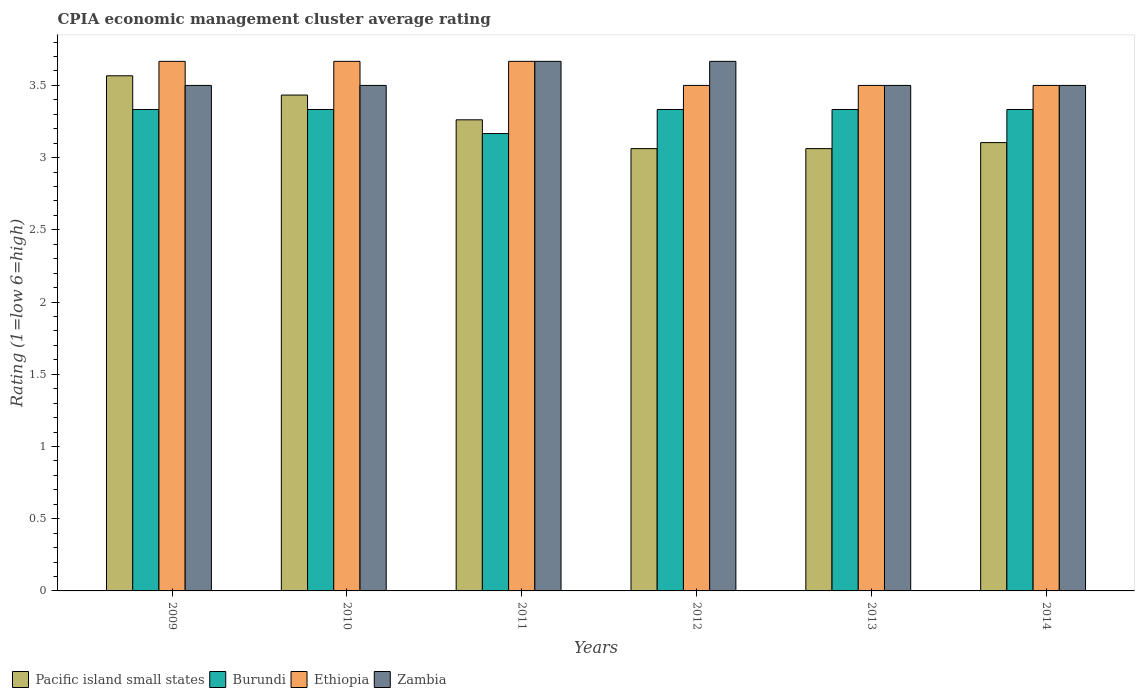Are the number of bars per tick equal to the number of legend labels?
Offer a very short reply. Yes. How many bars are there on the 2nd tick from the left?
Make the answer very short. 4. How many bars are there on the 4th tick from the right?
Your answer should be very brief. 4. What is the label of the 5th group of bars from the left?
Your answer should be very brief. 2013. What is the CPIA rating in Ethiopia in 2011?
Your response must be concise. 3.67. Across all years, what is the maximum CPIA rating in Zambia?
Ensure brevity in your answer.  3.67. Across all years, what is the minimum CPIA rating in Pacific island small states?
Keep it short and to the point. 3.06. What is the total CPIA rating in Zambia in the graph?
Provide a succinct answer. 21.33. What is the difference between the CPIA rating in Burundi in 2009 and that in 2013?
Provide a succinct answer. 0. What is the difference between the CPIA rating in Zambia in 2009 and the CPIA rating in Pacific island small states in 2013?
Provide a short and direct response. 0.44. What is the average CPIA rating in Pacific island small states per year?
Your answer should be very brief. 3.25. In the year 2012, what is the difference between the CPIA rating in Burundi and CPIA rating in Zambia?
Give a very brief answer. -0.33. What is the ratio of the CPIA rating in Burundi in 2009 to that in 2011?
Provide a short and direct response. 1.05. Is the difference between the CPIA rating in Burundi in 2013 and 2014 greater than the difference between the CPIA rating in Zambia in 2013 and 2014?
Provide a short and direct response. Yes. What is the difference between the highest and the second highest CPIA rating in Ethiopia?
Provide a short and direct response. 0. What is the difference between the highest and the lowest CPIA rating in Ethiopia?
Keep it short and to the point. 0.17. Is the sum of the CPIA rating in Burundi in 2011 and 2014 greater than the maximum CPIA rating in Pacific island small states across all years?
Your answer should be compact. Yes. What does the 3rd bar from the left in 2013 represents?
Offer a terse response. Ethiopia. What does the 1st bar from the right in 2011 represents?
Make the answer very short. Zambia. Is it the case that in every year, the sum of the CPIA rating in Zambia and CPIA rating in Burundi is greater than the CPIA rating in Pacific island small states?
Make the answer very short. Yes. How many years are there in the graph?
Provide a short and direct response. 6. Does the graph contain grids?
Your response must be concise. No. What is the title of the graph?
Provide a short and direct response. CPIA economic management cluster average rating. What is the Rating (1=low 6=high) in Pacific island small states in 2009?
Provide a succinct answer. 3.57. What is the Rating (1=low 6=high) in Burundi in 2009?
Give a very brief answer. 3.33. What is the Rating (1=low 6=high) of Ethiopia in 2009?
Offer a very short reply. 3.67. What is the Rating (1=low 6=high) of Pacific island small states in 2010?
Provide a short and direct response. 3.43. What is the Rating (1=low 6=high) in Burundi in 2010?
Keep it short and to the point. 3.33. What is the Rating (1=low 6=high) in Ethiopia in 2010?
Give a very brief answer. 3.67. What is the Rating (1=low 6=high) in Zambia in 2010?
Your answer should be very brief. 3.5. What is the Rating (1=low 6=high) in Pacific island small states in 2011?
Offer a terse response. 3.26. What is the Rating (1=low 6=high) of Burundi in 2011?
Your response must be concise. 3.17. What is the Rating (1=low 6=high) in Ethiopia in 2011?
Your response must be concise. 3.67. What is the Rating (1=low 6=high) in Zambia in 2011?
Offer a very short reply. 3.67. What is the Rating (1=low 6=high) of Pacific island small states in 2012?
Ensure brevity in your answer.  3.06. What is the Rating (1=low 6=high) in Burundi in 2012?
Provide a short and direct response. 3.33. What is the Rating (1=low 6=high) in Ethiopia in 2012?
Provide a succinct answer. 3.5. What is the Rating (1=low 6=high) of Zambia in 2012?
Provide a succinct answer. 3.67. What is the Rating (1=low 6=high) of Pacific island small states in 2013?
Provide a short and direct response. 3.06. What is the Rating (1=low 6=high) of Burundi in 2013?
Provide a short and direct response. 3.33. What is the Rating (1=low 6=high) of Ethiopia in 2013?
Provide a succinct answer. 3.5. What is the Rating (1=low 6=high) in Zambia in 2013?
Keep it short and to the point. 3.5. What is the Rating (1=low 6=high) in Pacific island small states in 2014?
Your answer should be very brief. 3.1. What is the Rating (1=low 6=high) of Burundi in 2014?
Ensure brevity in your answer.  3.33. Across all years, what is the maximum Rating (1=low 6=high) of Pacific island small states?
Provide a succinct answer. 3.57. Across all years, what is the maximum Rating (1=low 6=high) in Burundi?
Provide a short and direct response. 3.33. Across all years, what is the maximum Rating (1=low 6=high) of Ethiopia?
Give a very brief answer. 3.67. Across all years, what is the maximum Rating (1=low 6=high) of Zambia?
Provide a short and direct response. 3.67. Across all years, what is the minimum Rating (1=low 6=high) of Pacific island small states?
Your answer should be compact. 3.06. Across all years, what is the minimum Rating (1=low 6=high) in Burundi?
Your response must be concise. 3.17. Across all years, what is the minimum Rating (1=low 6=high) in Zambia?
Offer a very short reply. 3.5. What is the total Rating (1=low 6=high) of Pacific island small states in the graph?
Your answer should be very brief. 19.49. What is the total Rating (1=low 6=high) in Burundi in the graph?
Your answer should be compact. 19.83. What is the total Rating (1=low 6=high) of Zambia in the graph?
Ensure brevity in your answer.  21.33. What is the difference between the Rating (1=low 6=high) in Pacific island small states in 2009 and that in 2010?
Your answer should be very brief. 0.13. What is the difference between the Rating (1=low 6=high) of Zambia in 2009 and that in 2010?
Your response must be concise. 0. What is the difference between the Rating (1=low 6=high) of Pacific island small states in 2009 and that in 2011?
Ensure brevity in your answer.  0.3. What is the difference between the Rating (1=low 6=high) in Burundi in 2009 and that in 2011?
Your response must be concise. 0.17. What is the difference between the Rating (1=low 6=high) in Pacific island small states in 2009 and that in 2012?
Keep it short and to the point. 0.5. What is the difference between the Rating (1=low 6=high) in Zambia in 2009 and that in 2012?
Make the answer very short. -0.17. What is the difference between the Rating (1=low 6=high) in Pacific island small states in 2009 and that in 2013?
Keep it short and to the point. 0.5. What is the difference between the Rating (1=low 6=high) of Burundi in 2009 and that in 2013?
Provide a succinct answer. 0. What is the difference between the Rating (1=low 6=high) of Zambia in 2009 and that in 2013?
Provide a short and direct response. 0. What is the difference between the Rating (1=low 6=high) in Pacific island small states in 2009 and that in 2014?
Ensure brevity in your answer.  0.46. What is the difference between the Rating (1=low 6=high) of Zambia in 2009 and that in 2014?
Your answer should be very brief. 0. What is the difference between the Rating (1=low 6=high) in Pacific island small states in 2010 and that in 2011?
Offer a very short reply. 0.17. What is the difference between the Rating (1=low 6=high) of Burundi in 2010 and that in 2011?
Offer a very short reply. 0.17. What is the difference between the Rating (1=low 6=high) in Zambia in 2010 and that in 2011?
Provide a succinct answer. -0.17. What is the difference between the Rating (1=low 6=high) in Pacific island small states in 2010 and that in 2012?
Offer a very short reply. 0.37. What is the difference between the Rating (1=low 6=high) of Burundi in 2010 and that in 2012?
Your response must be concise. 0. What is the difference between the Rating (1=low 6=high) of Ethiopia in 2010 and that in 2012?
Make the answer very short. 0.17. What is the difference between the Rating (1=low 6=high) of Pacific island small states in 2010 and that in 2013?
Provide a short and direct response. 0.37. What is the difference between the Rating (1=low 6=high) in Burundi in 2010 and that in 2013?
Offer a terse response. 0. What is the difference between the Rating (1=low 6=high) in Zambia in 2010 and that in 2013?
Your response must be concise. 0. What is the difference between the Rating (1=low 6=high) in Pacific island small states in 2010 and that in 2014?
Offer a terse response. 0.33. What is the difference between the Rating (1=low 6=high) of Burundi in 2010 and that in 2014?
Your response must be concise. 0. What is the difference between the Rating (1=low 6=high) in Zambia in 2010 and that in 2014?
Provide a short and direct response. 0. What is the difference between the Rating (1=low 6=high) of Pacific island small states in 2011 and that in 2012?
Your answer should be very brief. 0.2. What is the difference between the Rating (1=low 6=high) of Burundi in 2011 and that in 2012?
Make the answer very short. -0.17. What is the difference between the Rating (1=low 6=high) of Ethiopia in 2011 and that in 2012?
Keep it short and to the point. 0.17. What is the difference between the Rating (1=low 6=high) in Zambia in 2011 and that in 2012?
Ensure brevity in your answer.  0. What is the difference between the Rating (1=low 6=high) in Pacific island small states in 2011 and that in 2013?
Your answer should be very brief. 0.2. What is the difference between the Rating (1=low 6=high) of Burundi in 2011 and that in 2013?
Offer a very short reply. -0.17. What is the difference between the Rating (1=low 6=high) in Ethiopia in 2011 and that in 2013?
Your answer should be very brief. 0.17. What is the difference between the Rating (1=low 6=high) in Pacific island small states in 2011 and that in 2014?
Provide a short and direct response. 0.16. What is the difference between the Rating (1=low 6=high) of Burundi in 2011 and that in 2014?
Your answer should be compact. -0.17. What is the difference between the Rating (1=low 6=high) in Pacific island small states in 2012 and that in 2013?
Ensure brevity in your answer.  0. What is the difference between the Rating (1=low 6=high) of Ethiopia in 2012 and that in 2013?
Your answer should be very brief. 0. What is the difference between the Rating (1=low 6=high) of Zambia in 2012 and that in 2013?
Give a very brief answer. 0.17. What is the difference between the Rating (1=low 6=high) of Pacific island small states in 2012 and that in 2014?
Your response must be concise. -0.04. What is the difference between the Rating (1=low 6=high) in Ethiopia in 2012 and that in 2014?
Your answer should be compact. 0. What is the difference between the Rating (1=low 6=high) of Zambia in 2012 and that in 2014?
Provide a short and direct response. 0.17. What is the difference between the Rating (1=low 6=high) of Pacific island small states in 2013 and that in 2014?
Provide a succinct answer. -0.04. What is the difference between the Rating (1=low 6=high) of Burundi in 2013 and that in 2014?
Keep it short and to the point. 0. What is the difference between the Rating (1=low 6=high) of Ethiopia in 2013 and that in 2014?
Your answer should be very brief. 0. What is the difference between the Rating (1=low 6=high) of Pacific island small states in 2009 and the Rating (1=low 6=high) of Burundi in 2010?
Provide a succinct answer. 0.23. What is the difference between the Rating (1=low 6=high) in Pacific island small states in 2009 and the Rating (1=low 6=high) in Ethiopia in 2010?
Offer a very short reply. -0.1. What is the difference between the Rating (1=low 6=high) in Pacific island small states in 2009 and the Rating (1=low 6=high) in Zambia in 2010?
Offer a very short reply. 0.07. What is the difference between the Rating (1=low 6=high) of Burundi in 2009 and the Rating (1=low 6=high) of Ethiopia in 2010?
Provide a succinct answer. -0.33. What is the difference between the Rating (1=low 6=high) in Burundi in 2009 and the Rating (1=low 6=high) in Zambia in 2010?
Ensure brevity in your answer.  -0.17. What is the difference between the Rating (1=low 6=high) in Burundi in 2009 and the Rating (1=low 6=high) in Zambia in 2011?
Your answer should be very brief. -0.33. What is the difference between the Rating (1=low 6=high) in Pacific island small states in 2009 and the Rating (1=low 6=high) in Burundi in 2012?
Give a very brief answer. 0.23. What is the difference between the Rating (1=low 6=high) of Pacific island small states in 2009 and the Rating (1=low 6=high) of Ethiopia in 2012?
Ensure brevity in your answer.  0.07. What is the difference between the Rating (1=low 6=high) in Pacific island small states in 2009 and the Rating (1=low 6=high) in Zambia in 2012?
Your answer should be very brief. -0.1. What is the difference between the Rating (1=low 6=high) of Burundi in 2009 and the Rating (1=low 6=high) of Zambia in 2012?
Your response must be concise. -0.33. What is the difference between the Rating (1=low 6=high) of Pacific island small states in 2009 and the Rating (1=low 6=high) of Burundi in 2013?
Offer a very short reply. 0.23. What is the difference between the Rating (1=low 6=high) of Pacific island small states in 2009 and the Rating (1=low 6=high) of Ethiopia in 2013?
Keep it short and to the point. 0.07. What is the difference between the Rating (1=low 6=high) in Pacific island small states in 2009 and the Rating (1=low 6=high) in Zambia in 2013?
Offer a terse response. 0.07. What is the difference between the Rating (1=low 6=high) in Burundi in 2009 and the Rating (1=low 6=high) in Ethiopia in 2013?
Provide a succinct answer. -0.17. What is the difference between the Rating (1=low 6=high) in Burundi in 2009 and the Rating (1=low 6=high) in Zambia in 2013?
Your response must be concise. -0.17. What is the difference between the Rating (1=low 6=high) in Ethiopia in 2009 and the Rating (1=low 6=high) in Zambia in 2013?
Keep it short and to the point. 0.17. What is the difference between the Rating (1=low 6=high) of Pacific island small states in 2009 and the Rating (1=low 6=high) of Burundi in 2014?
Your response must be concise. 0.23. What is the difference between the Rating (1=low 6=high) of Pacific island small states in 2009 and the Rating (1=low 6=high) of Ethiopia in 2014?
Offer a terse response. 0.07. What is the difference between the Rating (1=low 6=high) in Pacific island small states in 2009 and the Rating (1=low 6=high) in Zambia in 2014?
Your response must be concise. 0.07. What is the difference between the Rating (1=low 6=high) in Burundi in 2009 and the Rating (1=low 6=high) in Zambia in 2014?
Offer a very short reply. -0.17. What is the difference between the Rating (1=low 6=high) in Pacific island small states in 2010 and the Rating (1=low 6=high) in Burundi in 2011?
Offer a terse response. 0.27. What is the difference between the Rating (1=low 6=high) in Pacific island small states in 2010 and the Rating (1=low 6=high) in Ethiopia in 2011?
Your response must be concise. -0.23. What is the difference between the Rating (1=low 6=high) of Pacific island small states in 2010 and the Rating (1=low 6=high) of Zambia in 2011?
Ensure brevity in your answer.  -0.23. What is the difference between the Rating (1=low 6=high) in Ethiopia in 2010 and the Rating (1=low 6=high) in Zambia in 2011?
Your answer should be compact. 0. What is the difference between the Rating (1=low 6=high) in Pacific island small states in 2010 and the Rating (1=low 6=high) in Burundi in 2012?
Give a very brief answer. 0.1. What is the difference between the Rating (1=low 6=high) of Pacific island small states in 2010 and the Rating (1=low 6=high) of Ethiopia in 2012?
Give a very brief answer. -0.07. What is the difference between the Rating (1=low 6=high) in Pacific island small states in 2010 and the Rating (1=low 6=high) in Zambia in 2012?
Ensure brevity in your answer.  -0.23. What is the difference between the Rating (1=low 6=high) of Burundi in 2010 and the Rating (1=low 6=high) of Ethiopia in 2012?
Make the answer very short. -0.17. What is the difference between the Rating (1=low 6=high) of Ethiopia in 2010 and the Rating (1=low 6=high) of Zambia in 2012?
Give a very brief answer. 0. What is the difference between the Rating (1=low 6=high) in Pacific island small states in 2010 and the Rating (1=low 6=high) in Burundi in 2013?
Provide a succinct answer. 0.1. What is the difference between the Rating (1=low 6=high) in Pacific island small states in 2010 and the Rating (1=low 6=high) in Ethiopia in 2013?
Keep it short and to the point. -0.07. What is the difference between the Rating (1=low 6=high) in Pacific island small states in 2010 and the Rating (1=low 6=high) in Zambia in 2013?
Ensure brevity in your answer.  -0.07. What is the difference between the Rating (1=low 6=high) in Ethiopia in 2010 and the Rating (1=low 6=high) in Zambia in 2013?
Your answer should be compact. 0.17. What is the difference between the Rating (1=low 6=high) of Pacific island small states in 2010 and the Rating (1=low 6=high) of Ethiopia in 2014?
Give a very brief answer. -0.07. What is the difference between the Rating (1=low 6=high) of Pacific island small states in 2010 and the Rating (1=low 6=high) of Zambia in 2014?
Make the answer very short. -0.07. What is the difference between the Rating (1=low 6=high) of Burundi in 2010 and the Rating (1=low 6=high) of Ethiopia in 2014?
Your response must be concise. -0.17. What is the difference between the Rating (1=low 6=high) in Ethiopia in 2010 and the Rating (1=low 6=high) in Zambia in 2014?
Your answer should be very brief. 0.17. What is the difference between the Rating (1=low 6=high) of Pacific island small states in 2011 and the Rating (1=low 6=high) of Burundi in 2012?
Make the answer very short. -0.07. What is the difference between the Rating (1=low 6=high) in Pacific island small states in 2011 and the Rating (1=low 6=high) in Ethiopia in 2012?
Keep it short and to the point. -0.24. What is the difference between the Rating (1=low 6=high) of Pacific island small states in 2011 and the Rating (1=low 6=high) of Zambia in 2012?
Provide a succinct answer. -0.4. What is the difference between the Rating (1=low 6=high) in Ethiopia in 2011 and the Rating (1=low 6=high) in Zambia in 2012?
Give a very brief answer. 0. What is the difference between the Rating (1=low 6=high) in Pacific island small states in 2011 and the Rating (1=low 6=high) in Burundi in 2013?
Ensure brevity in your answer.  -0.07. What is the difference between the Rating (1=low 6=high) of Pacific island small states in 2011 and the Rating (1=low 6=high) of Ethiopia in 2013?
Offer a very short reply. -0.24. What is the difference between the Rating (1=low 6=high) of Pacific island small states in 2011 and the Rating (1=low 6=high) of Zambia in 2013?
Keep it short and to the point. -0.24. What is the difference between the Rating (1=low 6=high) of Burundi in 2011 and the Rating (1=low 6=high) of Ethiopia in 2013?
Your answer should be compact. -0.33. What is the difference between the Rating (1=low 6=high) in Pacific island small states in 2011 and the Rating (1=low 6=high) in Burundi in 2014?
Ensure brevity in your answer.  -0.07. What is the difference between the Rating (1=low 6=high) of Pacific island small states in 2011 and the Rating (1=low 6=high) of Ethiopia in 2014?
Your answer should be compact. -0.24. What is the difference between the Rating (1=low 6=high) of Pacific island small states in 2011 and the Rating (1=low 6=high) of Zambia in 2014?
Make the answer very short. -0.24. What is the difference between the Rating (1=low 6=high) in Pacific island small states in 2012 and the Rating (1=low 6=high) in Burundi in 2013?
Offer a terse response. -0.27. What is the difference between the Rating (1=low 6=high) in Pacific island small states in 2012 and the Rating (1=low 6=high) in Ethiopia in 2013?
Offer a terse response. -0.44. What is the difference between the Rating (1=low 6=high) in Pacific island small states in 2012 and the Rating (1=low 6=high) in Zambia in 2013?
Your answer should be very brief. -0.44. What is the difference between the Rating (1=low 6=high) of Burundi in 2012 and the Rating (1=low 6=high) of Ethiopia in 2013?
Your answer should be very brief. -0.17. What is the difference between the Rating (1=low 6=high) of Burundi in 2012 and the Rating (1=low 6=high) of Zambia in 2013?
Your answer should be compact. -0.17. What is the difference between the Rating (1=low 6=high) in Ethiopia in 2012 and the Rating (1=low 6=high) in Zambia in 2013?
Your answer should be very brief. 0. What is the difference between the Rating (1=low 6=high) of Pacific island small states in 2012 and the Rating (1=low 6=high) of Burundi in 2014?
Provide a succinct answer. -0.27. What is the difference between the Rating (1=low 6=high) of Pacific island small states in 2012 and the Rating (1=low 6=high) of Ethiopia in 2014?
Provide a short and direct response. -0.44. What is the difference between the Rating (1=low 6=high) of Pacific island small states in 2012 and the Rating (1=low 6=high) of Zambia in 2014?
Provide a succinct answer. -0.44. What is the difference between the Rating (1=low 6=high) of Burundi in 2012 and the Rating (1=low 6=high) of Zambia in 2014?
Your answer should be very brief. -0.17. What is the difference between the Rating (1=low 6=high) in Pacific island small states in 2013 and the Rating (1=low 6=high) in Burundi in 2014?
Make the answer very short. -0.27. What is the difference between the Rating (1=low 6=high) of Pacific island small states in 2013 and the Rating (1=low 6=high) of Ethiopia in 2014?
Offer a terse response. -0.44. What is the difference between the Rating (1=low 6=high) in Pacific island small states in 2013 and the Rating (1=low 6=high) in Zambia in 2014?
Give a very brief answer. -0.44. What is the difference between the Rating (1=low 6=high) of Burundi in 2013 and the Rating (1=low 6=high) of Ethiopia in 2014?
Offer a very short reply. -0.17. What is the difference between the Rating (1=low 6=high) in Ethiopia in 2013 and the Rating (1=low 6=high) in Zambia in 2014?
Your response must be concise. 0. What is the average Rating (1=low 6=high) of Pacific island small states per year?
Offer a terse response. 3.25. What is the average Rating (1=low 6=high) of Burundi per year?
Give a very brief answer. 3.31. What is the average Rating (1=low 6=high) in Ethiopia per year?
Keep it short and to the point. 3.58. What is the average Rating (1=low 6=high) of Zambia per year?
Keep it short and to the point. 3.56. In the year 2009, what is the difference between the Rating (1=low 6=high) of Pacific island small states and Rating (1=low 6=high) of Burundi?
Ensure brevity in your answer.  0.23. In the year 2009, what is the difference between the Rating (1=low 6=high) of Pacific island small states and Rating (1=low 6=high) of Ethiopia?
Your answer should be very brief. -0.1. In the year 2009, what is the difference between the Rating (1=low 6=high) in Pacific island small states and Rating (1=low 6=high) in Zambia?
Your response must be concise. 0.07. In the year 2009, what is the difference between the Rating (1=low 6=high) of Ethiopia and Rating (1=low 6=high) of Zambia?
Offer a terse response. 0.17. In the year 2010, what is the difference between the Rating (1=low 6=high) of Pacific island small states and Rating (1=low 6=high) of Burundi?
Give a very brief answer. 0.1. In the year 2010, what is the difference between the Rating (1=low 6=high) in Pacific island small states and Rating (1=low 6=high) in Ethiopia?
Offer a very short reply. -0.23. In the year 2010, what is the difference between the Rating (1=low 6=high) in Pacific island small states and Rating (1=low 6=high) in Zambia?
Provide a short and direct response. -0.07. In the year 2011, what is the difference between the Rating (1=low 6=high) of Pacific island small states and Rating (1=low 6=high) of Burundi?
Ensure brevity in your answer.  0.1. In the year 2011, what is the difference between the Rating (1=low 6=high) of Pacific island small states and Rating (1=low 6=high) of Ethiopia?
Provide a succinct answer. -0.4. In the year 2011, what is the difference between the Rating (1=low 6=high) in Pacific island small states and Rating (1=low 6=high) in Zambia?
Your answer should be very brief. -0.4. In the year 2011, what is the difference between the Rating (1=low 6=high) in Burundi and Rating (1=low 6=high) in Zambia?
Make the answer very short. -0.5. In the year 2012, what is the difference between the Rating (1=low 6=high) in Pacific island small states and Rating (1=low 6=high) in Burundi?
Offer a terse response. -0.27. In the year 2012, what is the difference between the Rating (1=low 6=high) of Pacific island small states and Rating (1=low 6=high) of Ethiopia?
Make the answer very short. -0.44. In the year 2012, what is the difference between the Rating (1=low 6=high) in Pacific island small states and Rating (1=low 6=high) in Zambia?
Keep it short and to the point. -0.6. In the year 2012, what is the difference between the Rating (1=low 6=high) of Burundi and Rating (1=low 6=high) of Ethiopia?
Ensure brevity in your answer.  -0.17. In the year 2012, what is the difference between the Rating (1=low 6=high) in Ethiopia and Rating (1=low 6=high) in Zambia?
Your response must be concise. -0.17. In the year 2013, what is the difference between the Rating (1=low 6=high) of Pacific island small states and Rating (1=low 6=high) of Burundi?
Your answer should be compact. -0.27. In the year 2013, what is the difference between the Rating (1=low 6=high) in Pacific island small states and Rating (1=low 6=high) in Ethiopia?
Your response must be concise. -0.44. In the year 2013, what is the difference between the Rating (1=low 6=high) in Pacific island small states and Rating (1=low 6=high) in Zambia?
Your answer should be compact. -0.44. In the year 2013, what is the difference between the Rating (1=low 6=high) in Burundi and Rating (1=low 6=high) in Ethiopia?
Give a very brief answer. -0.17. In the year 2014, what is the difference between the Rating (1=low 6=high) of Pacific island small states and Rating (1=low 6=high) of Burundi?
Give a very brief answer. -0.23. In the year 2014, what is the difference between the Rating (1=low 6=high) of Pacific island small states and Rating (1=low 6=high) of Ethiopia?
Offer a terse response. -0.4. In the year 2014, what is the difference between the Rating (1=low 6=high) of Pacific island small states and Rating (1=low 6=high) of Zambia?
Provide a succinct answer. -0.4. In the year 2014, what is the difference between the Rating (1=low 6=high) of Burundi and Rating (1=low 6=high) of Ethiopia?
Offer a very short reply. -0.17. In the year 2014, what is the difference between the Rating (1=low 6=high) in Ethiopia and Rating (1=low 6=high) in Zambia?
Offer a very short reply. 0. What is the ratio of the Rating (1=low 6=high) in Pacific island small states in 2009 to that in 2010?
Your answer should be very brief. 1.04. What is the ratio of the Rating (1=low 6=high) in Burundi in 2009 to that in 2010?
Give a very brief answer. 1. What is the ratio of the Rating (1=low 6=high) in Pacific island small states in 2009 to that in 2011?
Your answer should be compact. 1.09. What is the ratio of the Rating (1=low 6=high) in Burundi in 2009 to that in 2011?
Provide a short and direct response. 1.05. What is the ratio of the Rating (1=low 6=high) in Ethiopia in 2009 to that in 2011?
Give a very brief answer. 1. What is the ratio of the Rating (1=low 6=high) in Zambia in 2009 to that in 2011?
Your answer should be compact. 0.95. What is the ratio of the Rating (1=low 6=high) in Pacific island small states in 2009 to that in 2012?
Make the answer very short. 1.16. What is the ratio of the Rating (1=low 6=high) of Burundi in 2009 to that in 2012?
Give a very brief answer. 1. What is the ratio of the Rating (1=low 6=high) in Ethiopia in 2009 to that in 2012?
Keep it short and to the point. 1.05. What is the ratio of the Rating (1=low 6=high) in Zambia in 2009 to that in 2012?
Provide a short and direct response. 0.95. What is the ratio of the Rating (1=low 6=high) in Pacific island small states in 2009 to that in 2013?
Keep it short and to the point. 1.16. What is the ratio of the Rating (1=low 6=high) in Burundi in 2009 to that in 2013?
Give a very brief answer. 1. What is the ratio of the Rating (1=low 6=high) of Ethiopia in 2009 to that in 2013?
Offer a terse response. 1.05. What is the ratio of the Rating (1=low 6=high) in Pacific island small states in 2009 to that in 2014?
Ensure brevity in your answer.  1.15. What is the ratio of the Rating (1=low 6=high) of Burundi in 2009 to that in 2014?
Offer a terse response. 1. What is the ratio of the Rating (1=low 6=high) of Ethiopia in 2009 to that in 2014?
Ensure brevity in your answer.  1.05. What is the ratio of the Rating (1=low 6=high) in Pacific island small states in 2010 to that in 2011?
Your answer should be compact. 1.05. What is the ratio of the Rating (1=low 6=high) of Burundi in 2010 to that in 2011?
Your answer should be very brief. 1.05. What is the ratio of the Rating (1=low 6=high) in Ethiopia in 2010 to that in 2011?
Offer a very short reply. 1. What is the ratio of the Rating (1=low 6=high) in Zambia in 2010 to that in 2011?
Your answer should be compact. 0.95. What is the ratio of the Rating (1=low 6=high) of Pacific island small states in 2010 to that in 2012?
Keep it short and to the point. 1.12. What is the ratio of the Rating (1=low 6=high) of Burundi in 2010 to that in 2012?
Offer a terse response. 1. What is the ratio of the Rating (1=low 6=high) in Ethiopia in 2010 to that in 2012?
Offer a very short reply. 1.05. What is the ratio of the Rating (1=low 6=high) of Zambia in 2010 to that in 2012?
Your response must be concise. 0.95. What is the ratio of the Rating (1=low 6=high) in Pacific island small states in 2010 to that in 2013?
Ensure brevity in your answer.  1.12. What is the ratio of the Rating (1=low 6=high) in Ethiopia in 2010 to that in 2013?
Your answer should be compact. 1.05. What is the ratio of the Rating (1=low 6=high) in Pacific island small states in 2010 to that in 2014?
Offer a terse response. 1.11. What is the ratio of the Rating (1=low 6=high) in Ethiopia in 2010 to that in 2014?
Your response must be concise. 1.05. What is the ratio of the Rating (1=low 6=high) in Zambia in 2010 to that in 2014?
Your response must be concise. 1. What is the ratio of the Rating (1=low 6=high) of Pacific island small states in 2011 to that in 2012?
Provide a short and direct response. 1.07. What is the ratio of the Rating (1=low 6=high) in Ethiopia in 2011 to that in 2012?
Offer a very short reply. 1.05. What is the ratio of the Rating (1=low 6=high) of Pacific island small states in 2011 to that in 2013?
Your answer should be compact. 1.07. What is the ratio of the Rating (1=low 6=high) in Ethiopia in 2011 to that in 2013?
Your answer should be compact. 1.05. What is the ratio of the Rating (1=low 6=high) of Zambia in 2011 to that in 2013?
Make the answer very short. 1.05. What is the ratio of the Rating (1=low 6=high) of Pacific island small states in 2011 to that in 2014?
Keep it short and to the point. 1.05. What is the ratio of the Rating (1=low 6=high) in Burundi in 2011 to that in 2014?
Give a very brief answer. 0.95. What is the ratio of the Rating (1=low 6=high) in Ethiopia in 2011 to that in 2014?
Your answer should be compact. 1.05. What is the ratio of the Rating (1=low 6=high) of Zambia in 2011 to that in 2014?
Make the answer very short. 1.05. What is the ratio of the Rating (1=low 6=high) in Burundi in 2012 to that in 2013?
Provide a succinct answer. 1. What is the ratio of the Rating (1=low 6=high) in Zambia in 2012 to that in 2013?
Keep it short and to the point. 1.05. What is the ratio of the Rating (1=low 6=high) of Pacific island small states in 2012 to that in 2014?
Make the answer very short. 0.99. What is the ratio of the Rating (1=low 6=high) in Ethiopia in 2012 to that in 2014?
Provide a succinct answer. 1. What is the ratio of the Rating (1=low 6=high) in Zambia in 2012 to that in 2014?
Provide a short and direct response. 1.05. What is the ratio of the Rating (1=low 6=high) of Pacific island small states in 2013 to that in 2014?
Offer a terse response. 0.99. What is the difference between the highest and the second highest Rating (1=low 6=high) of Pacific island small states?
Your response must be concise. 0.13. What is the difference between the highest and the second highest Rating (1=low 6=high) of Burundi?
Keep it short and to the point. 0. What is the difference between the highest and the second highest Rating (1=low 6=high) in Ethiopia?
Give a very brief answer. 0. What is the difference between the highest and the second highest Rating (1=low 6=high) in Zambia?
Your answer should be compact. 0. What is the difference between the highest and the lowest Rating (1=low 6=high) of Pacific island small states?
Your answer should be compact. 0.5. What is the difference between the highest and the lowest Rating (1=low 6=high) in Burundi?
Offer a very short reply. 0.17. What is the difference between the highest and the lowest Rating (1=low 6=high) of Ethiopia?
Ensure brevity in your answer.  0.17. 